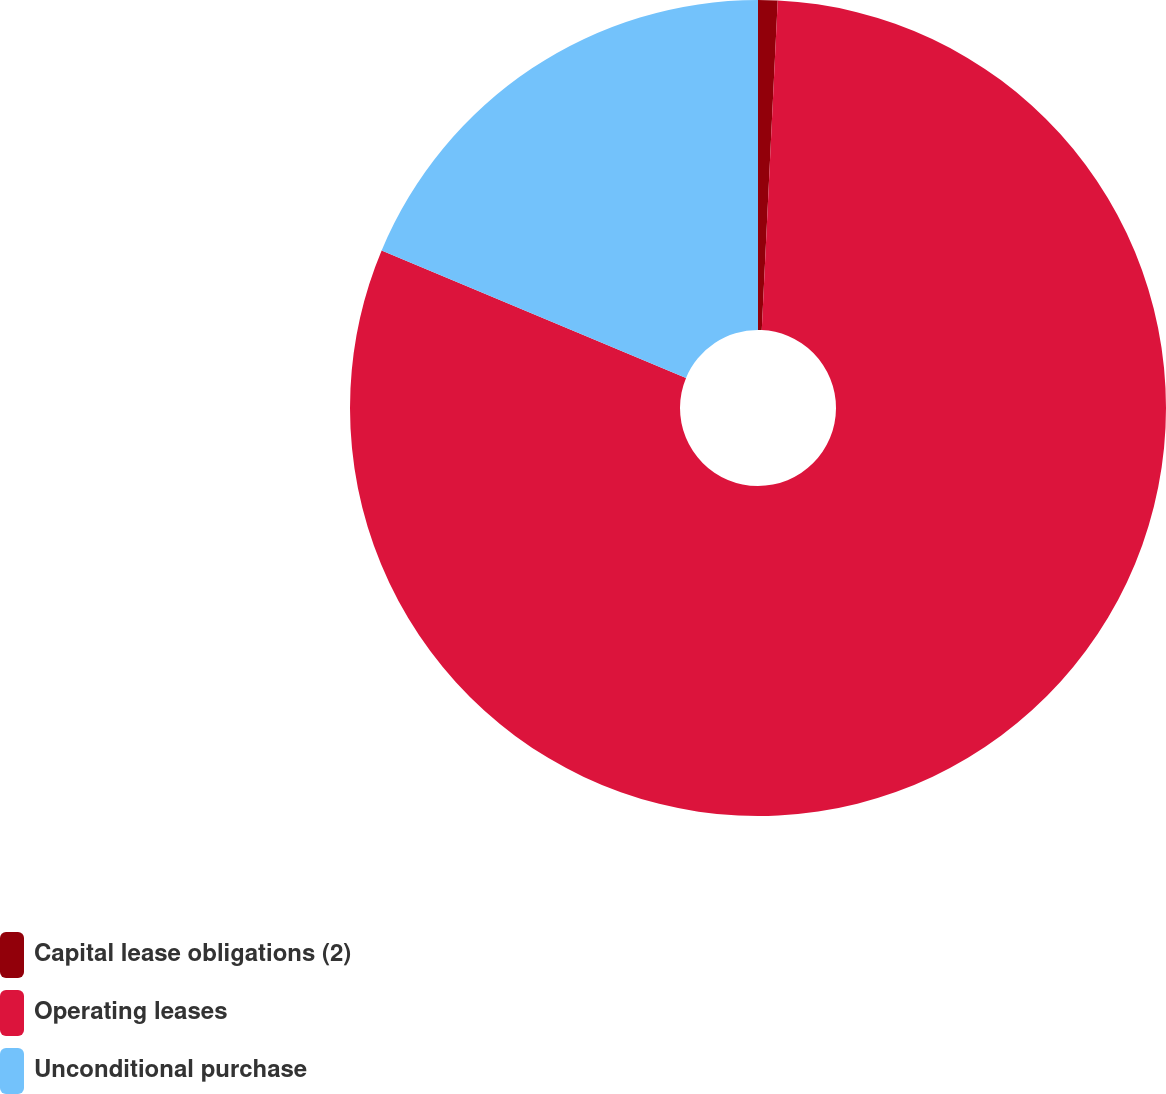Convert chart. <chart><loc_0><loc_0><loc_500><loc_500><pie_chart><fcel>Capital lease obligations (2)<fcel>Operating leases<fcel>Unconditional purchase<nl><fcel>0.77%<fcel>80.54%<fcel>18.69%<nl></chart> 